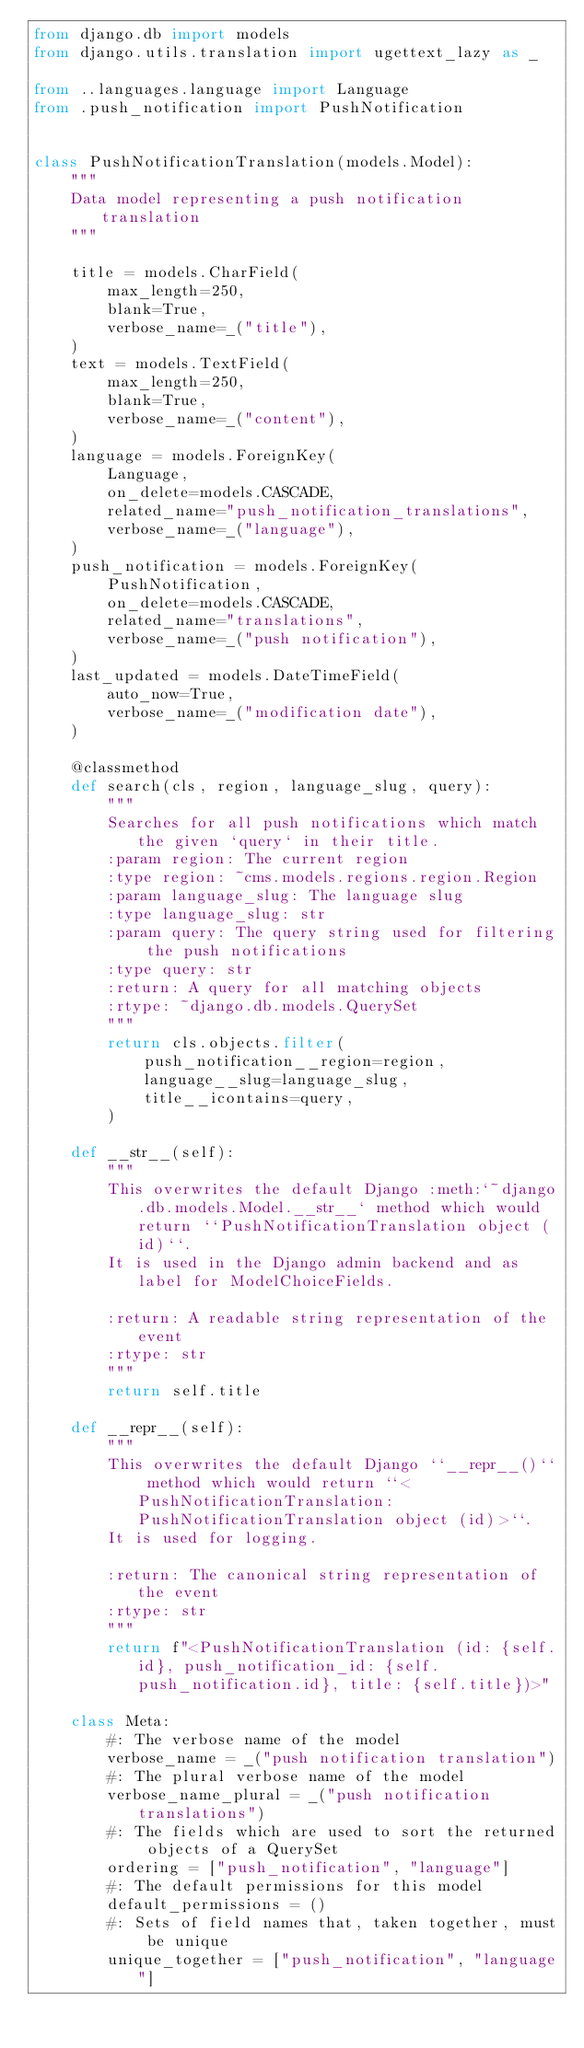<code> <loc_0><loc_0><loc_500><loc_500><_Python_>from django.db import models
from django.utils.translation import ugettext_lazy as _

from ..languages.language import Language
from .push_notification import PushNotification


class PushNotificationTranslation(models.Model):
    """
    Data model representing a push notification translation
    """

    title = models.CharField(
        max_length=250,
        blank=True,
        verbose_name=_("title"),
    )
    text = models.TextField(
        max_length=250,
        blank=True,
        verbose_name=_("content"),
    )
    language = models.ForeignKey(
        Language,
        on_delete=models.CASCADE,
        related_name="push_notification_translations",
        verbose_name=_("language"),
    )
    push_notification = models.ForeignKey(
        PushNotification,
        on_delete=models.CASCADE,
        related_name="translations",
        verbose_name=_("push notification"),
    )
    last_updated = models.DateTimeField(
        auto_now=True,
        verbose_name=_("modification date"),
    )

    @classmethod
    def search(cls, region, language_slug, query):
        """
        Searches for all push notifications which match the given `query` in their title.
        :param region: The current region
        :type region: ~cms.models.regions.region.Region
        :param language_slug: The language slug
        :type language_slug: str
        :param query: The query string used for filtering the push notifications
        :type query: str
        :return: A query for all matching objects
        :rtype: ~django.db.models.QuerySet
        """
        return cls.objects.filter(
            push_notification__region=region,
            language__slug=language_slug,
            title__icontains=query,
        )

    def __str__(self):
        """
        This overwrites the default Django :meth:`~django.db.models.Model.__str__` method which would return ``PushNotificationTranslation object (id)``.
        It is used in the Django admin backend and as label for ModelChoiceFields.

        :return: A readable string representation of the event
        :rtype: str
        """
        return self.title

    def __repr__(self):
        """
        This overwrites the default Django ``__repr__()`` method which would return ``<PushNotificationTranslation: PushNotificationTranslation object (id)>``.
        It is used for logging.

        :return: The canonical string representation of the event
        :rtype: str
        """
        return f"<PushNotificationTranslation (id: {self.id}, push_notification_id: {self.push_notification.id}, title: {self.title})>"

    class Meta:
        #: The verbose name of the model
        verbose_name = _("push notification translation")
        #: The plural verbose name of the model
        verbose_name_plural = _("push notification translations")
        #: The fields which are used to sort the returned objects of a QuerySet
        ordering = ["push_notification", "language"]
        #: The default permissions for this model
        default_permissions = ()
        #: Sets of field names that, taken together, must be unique
        unique_together = ["push_notification", "language"]
</code> 